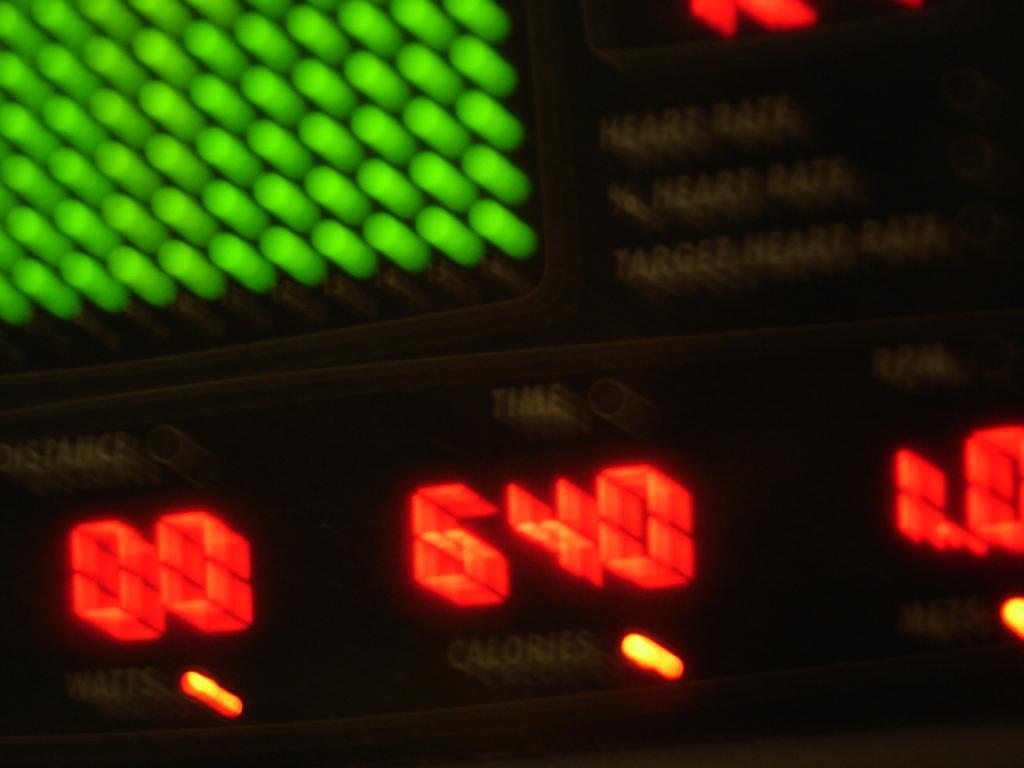Could you give a brief overview of what you see in this image? This is an image of a measuring meter and here we can see text with lightning. 